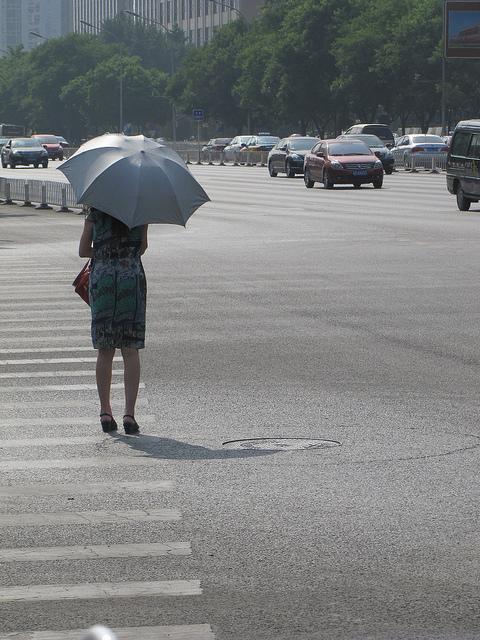Why is the umbrella so bright?
Quick response, please. It's sunny. How many parking spaces are there?
Give a very brief answer. 0. Is the woman at a flea market?
Keep it brief. No. Is this photo manipulated?
Answer briefly. No. Is it raining?
Short answer required. No. Is the lady doing something safe?
Short answer required. Yes. 